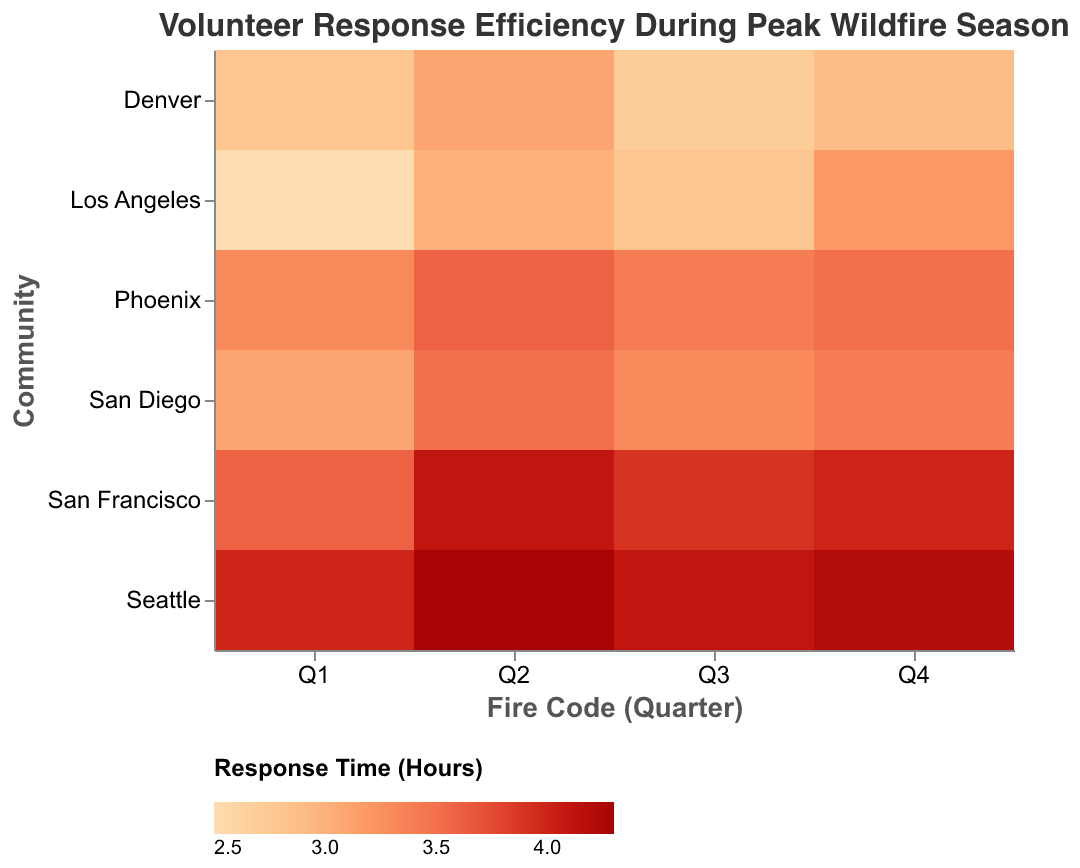What is the title of the heatmap? The title of the heatmap is located at the top of the figure. It typically provides a brief description of what the heatmap represents. In this case, the title is "Volunteer Response Efficiency During Peak Wildfire Season."
Answer: Volunteer Response Efficiency During Peak Wildfire Season Which community had the fastest response time in Q1? To find the fastest response time in Q1, look at the first column (Q1) and find the minimum value. For Q1, the lowest value is 2.5 hours for Los Angeles.
Answer: Los Angeles What is the range of response times depicted in the heatmap? The range can be determined by finding the minimum and maximum values in the data. This heatmap's color scale legend indicates a range from 2.5 to 4.3 hours.
Answer: 2.5 to 4.3 hours Which quarter had the longest response time in San Francisco? To find this, locate the row for San Francisco and determine which column (Q1, Q2, Q3, Q4) has the highest value. The highest response time for San Francisco is 4.1 hours in Q2.
Answer: Q2 Between Denver and Phoenix, which community had more consistent response times across all quarters? Consistency can be assessed by inspecting the variation in response times. Denver's values (2.8, 3.1, 2.7, 2.9) have a smaller range compared to Phoenix's values (3.3, 3.6, 3.4, 3.5). This indicates Denver had more consistent response times.
Answer: Denver In which quarter did Seattle have its slowest response time and what was it? Look at the row for Seattle and identify the column with the highest value. The slowest response time for Seattle was 4.3 hours in Q2.
Answer: Q2, 4.3 hours How does the response time in Q3 for Los Angeles compare to that in Q3 for Denver? Compare the response times for both communities in Q3. Los Angeles has a response time of 2.8 hours, while Denver has a response time of 2.7 hours; Denver is slightly faster.
Answer: Denver is faster What is the average response time for San Diego across all quarters? To find the average, sum the response times for San Diego across all quarters (3.1 + 3.5 + 3.3 + 3.4), then divide by the number of quarters (4). The sum is 13.3 and the average is 13.3/4 = 3.325 hours.
Answer: 3.325 hours Which community had the quickest overall response time and in which quarter? Identify the lowest overall value in the heatmap. The quickest response time is 2.5 hours, which occurred in Los Angeles during Q1.
Answer: Los Angeles, Q1 